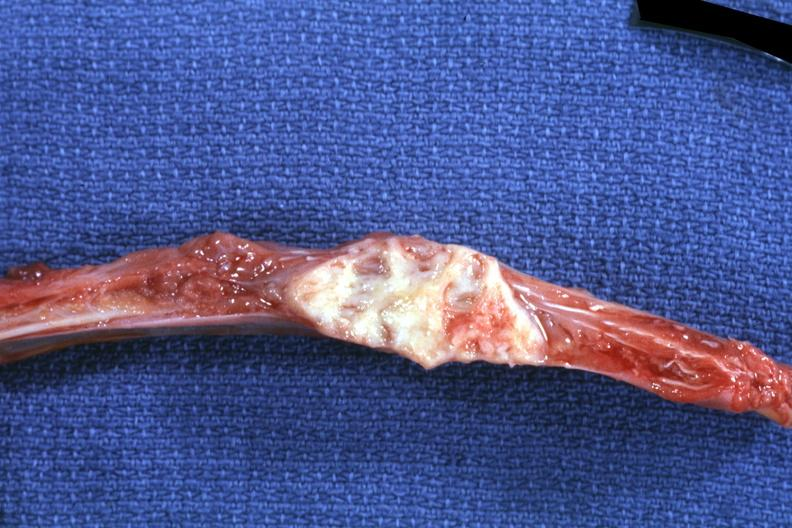does this image show rib with obvious focal lesion squamous cell carcinoma primary in penis?
Answer the question using a single word or phrase. Yes 